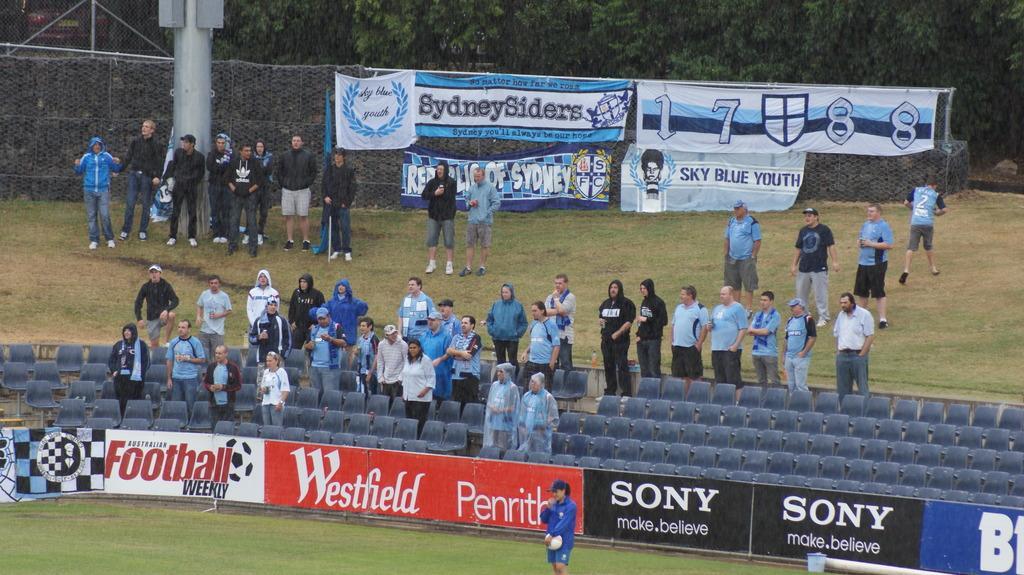In one or two sentences, can you explain what this image depicts? In this image we can see a group of people standing beside the chairs. We can also see a fence, a bucket and a person standing on the ground holding a ball. On the backside we can see some people standing beside a metal fence covered with some banners. We can also see a pole and a group of trees. 